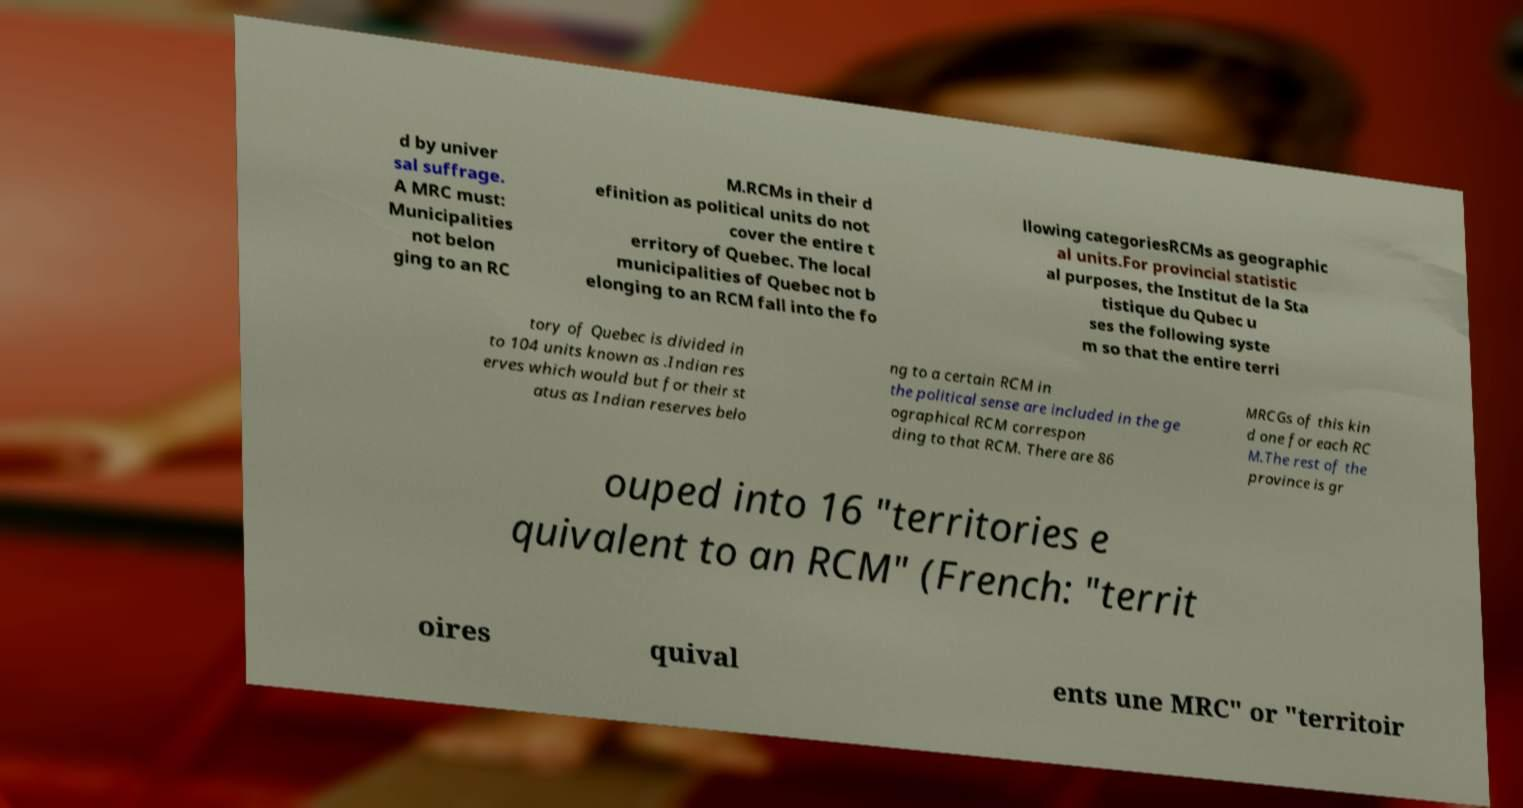Could you assist in decoding the text presented in this image and type it out clearly? d by univer sal suffrage. A MRC must: Municipalities not belon ging to an RC M.RCMs in their d efinition as political units do not cover the entire t erritory of Quebec. The local municipalities of Quebec not b elonging to an RCM fall into the fo llowing categoriesRCMs as geographic al units.For provincial statistic al purposes, the Institut de la Sta tistique du Qubec u ses the following syste m so that the entire terri tory of Quebec is divided in to 104 units known as .Indian res erves which would but for their st atus as Indian reserves belo ng to a certain RCM in the political sense are included in the ge ographical RCM correspon ding to that RCM. There are 86 MRCGs of this kin d one for each RC M.The rest of the province is gr ouped into 16 "territories e quivalent to an RCM" (French: "territ oires quival ents une MRC" or "territoir 